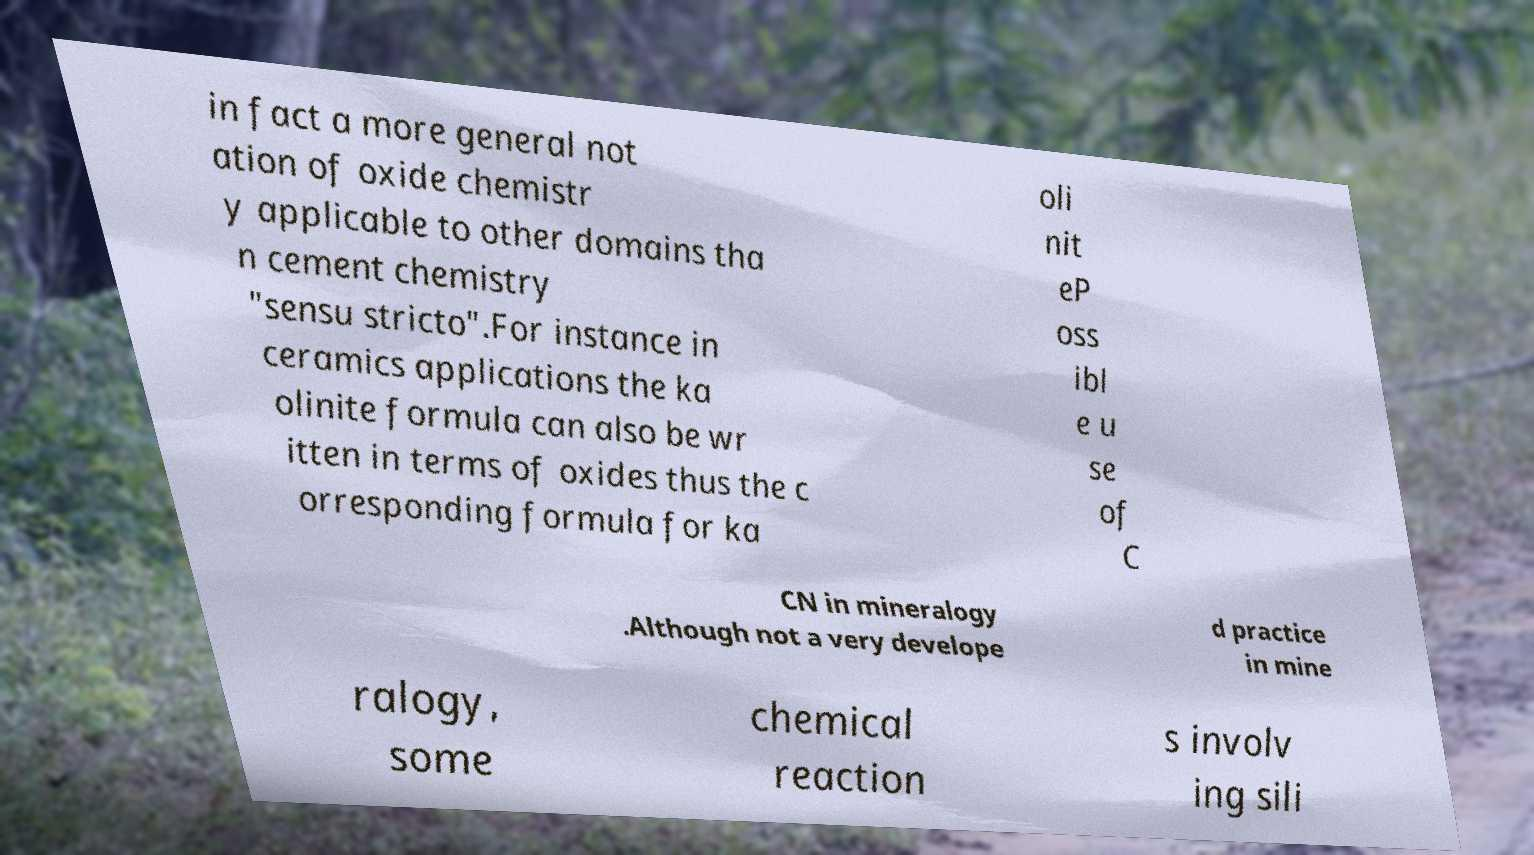Can you read and provide the text displayed in the image?This photo seems to have some interesting text. Can you extract and type it out for me? in fact a more general not ation of oxide chemistr y applicable to other domains tha n cement chemistry "sensu stricto".For instance in ceramics applications the ka olinite formula can also be wr itten in terms of oxides thus the c orresponding formula for ka oli nit eP oss ibl e u se of C CN in mineralogy .Although not a very develope d practice in mine ralogy, some chemical reaction s involv ing sili 